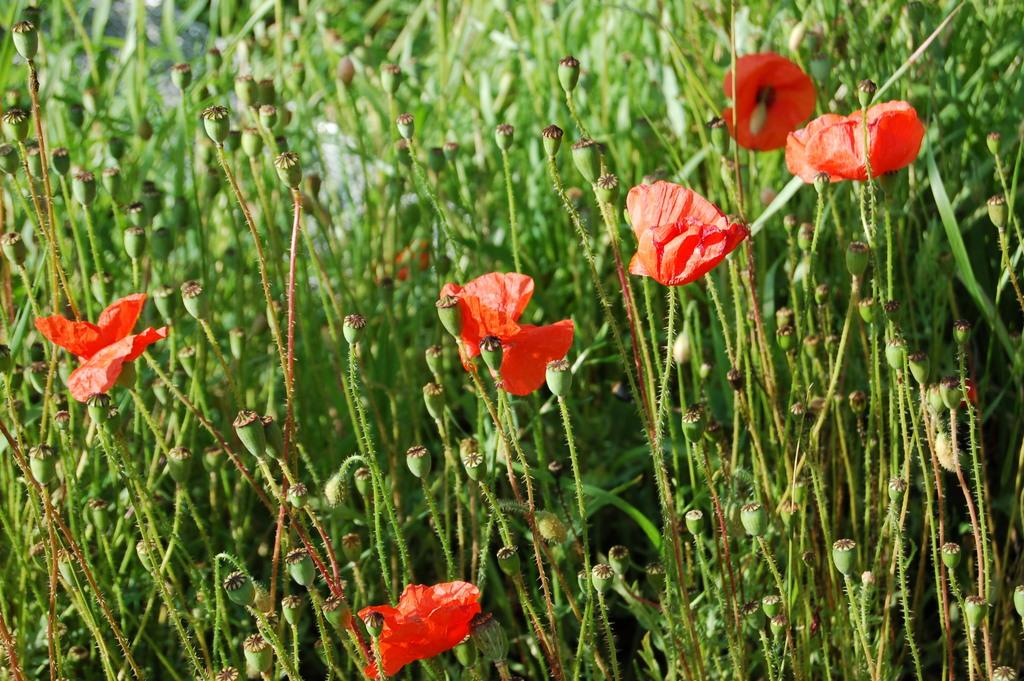What type of living organisms are present in the image? There are plants in the image. What specific features can be observed on the plants? The plants have flowers and buds. What color are the flowers on the plants? The flowers are in red color. What color are the buds on the plants? The buds are in green color. How would you describe the overall clarity of the image? The image is blurred in the background. What type of straw is being used to paint the flowers in the image? There is no straw or painting activity present in the image. The flowers are already in red color, and there is no indication of any painting or straw being used. 